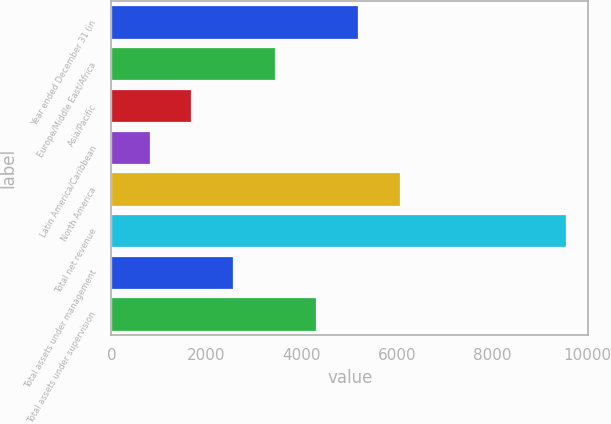Convert chart. <chart><loc_0><loc_0><loc_500><loc_500><bar_chart><fcel>Year ended December 31 (in<fcel>Europe/Middle East/Africa<fcel>Asia/Pacific<fcel>Latin America/Caribbean<fcel>North America<fcel>Total net revenue<fcel>Total assets under management<fcel>Total assets under supervision<nl><fcel>5175.5<fcel>3428.5<fcel>1681.5<fcel>808<fcel>6060<fcel>9543<fcel>2555<fcel>4302<nl></chart> 